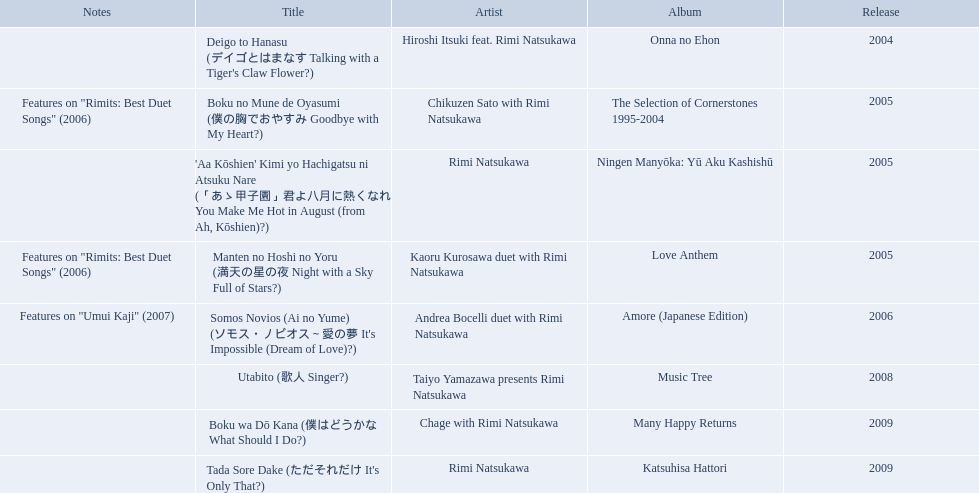What year was onna no ehon released? 2004. What year was music tree released? 2008. Which of the two was not released in 2004? Music Tree. 